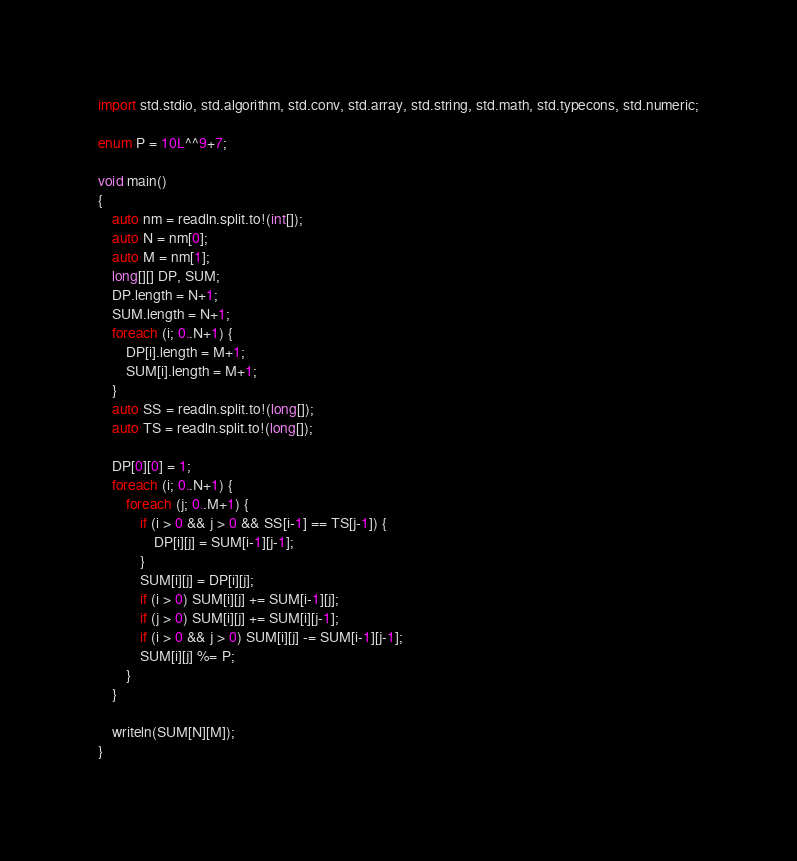<code> <loc_0><loc_0><loc_500><loc_500><_D_>import std.stdio, std.algorithm, std.conv, std.array, std.string, std.math, std.typecons, std.numeric;

enum P = 10L^^9+7;

void main()
{
    auto nm = readln.split.to!(int[]);
    auto N = nm[0];
    auto M = nm[1];
    long[][] DP, SUM;
    DP.length = N+1;
    SUM.length = N+1;
    foreach (i; 0..N+1) {
        DP[i].length = M+1;
        SUM[i].length = M+1;
    }
    auto SS = readln.split.to!(long[]);
    auto TS = readln.split.to!(long[]);

    DP[0][0] = 1;
    foreach (i; 0..N+1) {
        foreach (j; 0..M+1) {
            if (i > 0 && j > 0 && SS[i-1] == TS[j-1]) {
                DP[i][j] = SUM[i-1][j-1];
            }
            SUM[i][j] = DP[i][j];
            if (i > 0) SUM[i][j] += SUM[i-1][j];
            if (j > 0) SUM[i][j] += SUM[i][j-1];
            if (i > 0 && j > 0) SUM[i][j] -= SUM[i-1][j-1];
            SUM[i][j] %= P;
        }
    }

    writeln(SUM[N][M]);
}</code> 